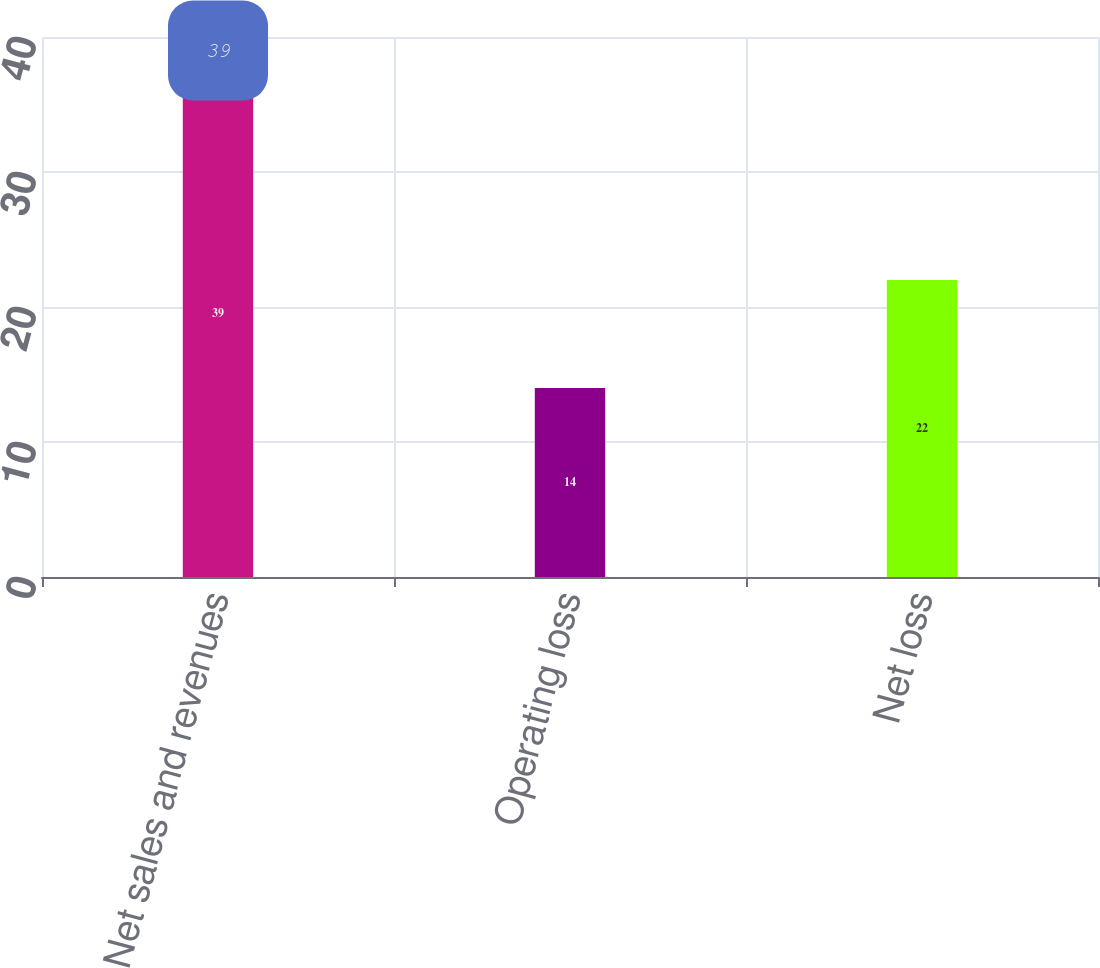Convert chart. <chart><loc_0><loc_0><loc_500><loc_500><bar_chart><fcel>Net sales and revenues<fcel>Operating loss<fcel>Net loss<nl><fcel>39<fcel>14<fcel>22<nl></chart> 